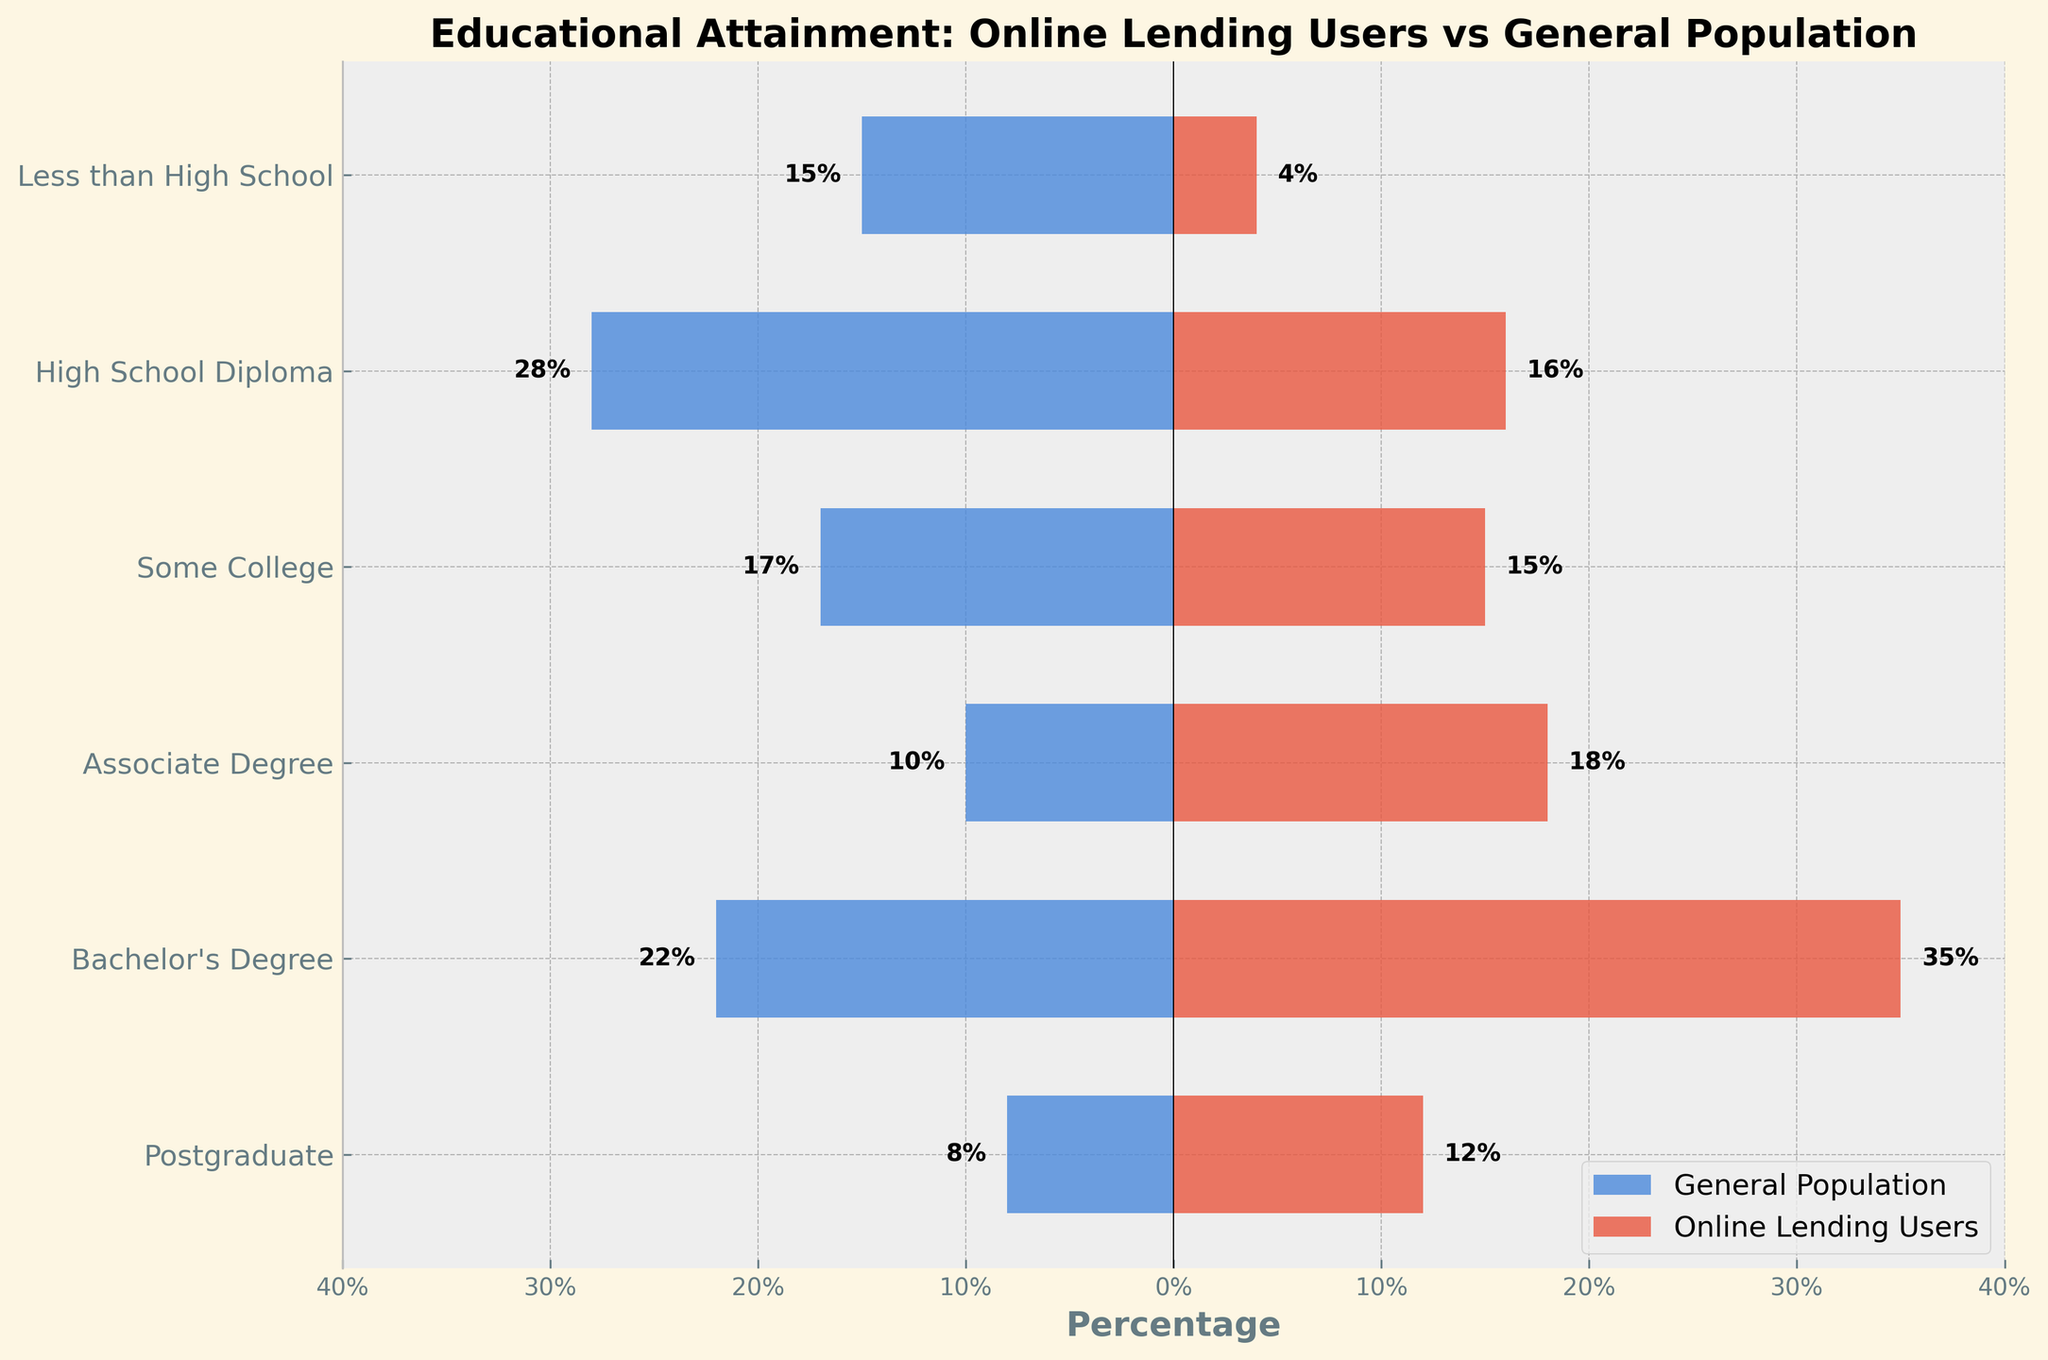What's the title of the figure? The title of the figure is displayed at the top and it provides an overview of the chart's content.
Answer: Educational Attainment: Online Lending Users vs General Population What does the x-axis represent? The x-axis represents the percentage of individuals within each educational attainment level.
Answer: Percentage Which educational group has the highest percentage of online lending users? The bar labeled for 'Bachelor's Degree' extends the farthest to the right, indicating it has the highest percentage among online lending users.
Answer: Bachelor's Degree In which educational level is the difference the greatest between online lending users and the general population? To determine this, we compare the length of the bars for each educational level between the right (online lending users) and left (general population). The 'Bachelor's Degree' group shows the most noticeable difference visually.
Answer: Bachelor's Degree What percentage of online lending users have a postgraduate degree? The bar corresponding to 'Postgraduate' on the online lending users side extends to 12%.
Answer: 12% Which group has a lower percentage among online lending users as compared to the general population? By comparing the lengths of the bars, the 'High School Diploma' and 'Less than High School' groups have shorter bars on the online lending users' side compared to the general population.
Answer: High School Diploma, Less than High School For the high school diploma level, what is the difference in the percentage between online lending users and the general population? Subtract the percentage of online lending users with a High School Diploma (16%) from the percentage of the general population with a High School Diploma (28%). The difference is 28% - 16% = 12%.
Answer: 12% Which group is closest in percentage between online lending users and the general population? By comparing the lengths of the bars, the 'Some College' category seems to have the closest percentages between online lending users (15%) and the general population (17%).
Answer: Some College What percentage of the general population has less than a high school education? The bar corresponding to 'Less than High School' on the general population side extends to 15%.
Answer: 15% In the associate degree category, how much higher is the percentage of online lending users compared to the general population? The percentage of online lending users with an Associate Degree is 18%, and for the general population, it is 10%. The difference is 18% - 10% = 8%.
Answer: 8% 